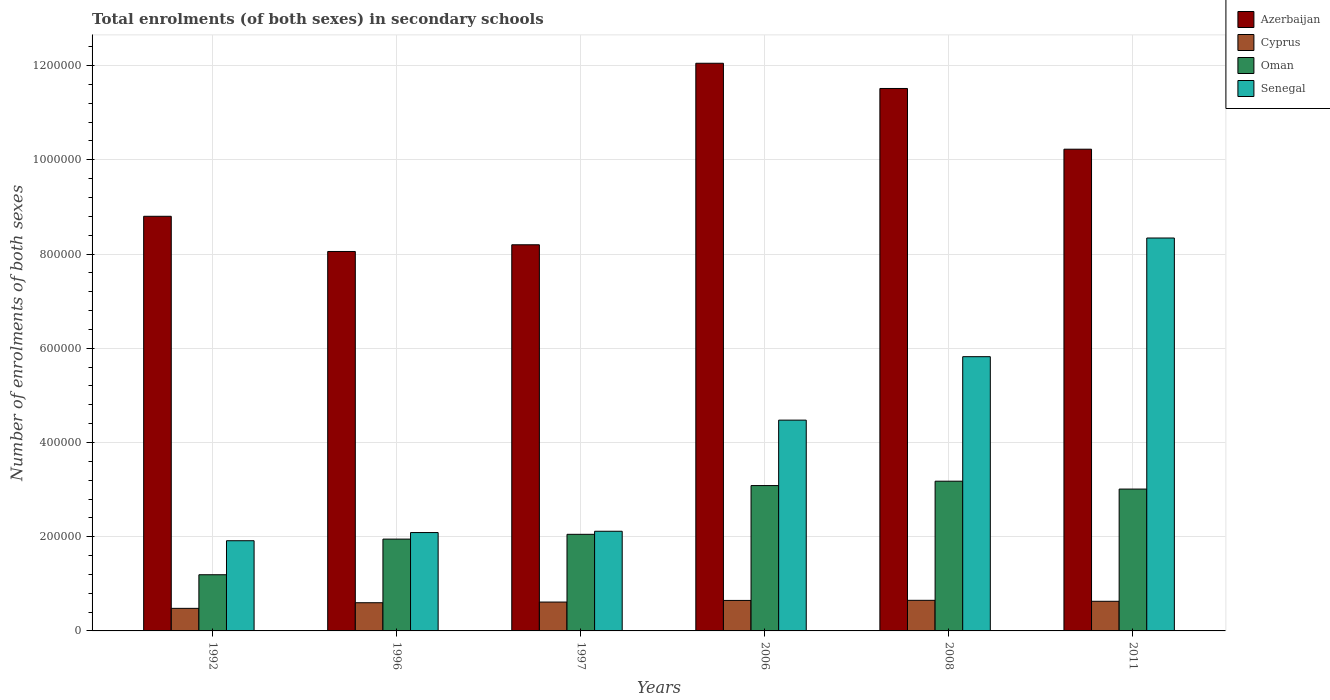How many different coloured bars are there?
Provide a short and direct response. 4. Are the number of bars per tick equal to the number of legend labels?
Your response must be concise. Yes. Are the number of bars on each tick of the X-axis equal?
Provide a succinct answer. Yes. What is the label of the 2nd group of bars from the left?
Keep it short and to the point. 1996. What is the number of enrolments in secondary schools in Oman in 1996?
Your answer should be very brief. 1.95e+05. Across all years, what is the maximum number of enrolments in secondary schools in Oman?
Offer a very short reply. 3.18e+05. Across all years, what is the minimum number of enrolments in secondary schools in Senegal?
Offer a terse response. 1.91e+05. In which year was the number of enrolments in secondary schools in Cyprus maximum?
Provide a short and direct response. 2008. In which year was the number of enrolments in secondary schools in Oman minimum?
Your answer should be compact. 1992. What is the total number of enrolments in secondary schools in Azerbaijan in the graph?
Your answer should be very brief. 5.88e+06. What is the difference between the number of enrolments in secondary schools in Azerbaijan in 2006 and that in 2011?
Provide a succinct answer. 1.82e+05. What is the difference between the number of enrolments in secondary schools in Cyprus in 1997 and the number of enrolments in secondary schools in Senegal in 1996?
Ensure brevity in your answer.  -1.48e+05. What is the average number of enrolments in secondary schools in Oman per year?
Provide a short and direct response. 2.41e+05. In the year 1992, what is the difference between the number of enrolments in secondary schools in Azerbaijan and number of enrolments in secondary schools in Oman?
Ensure brevity in your answer.  7.61e+05. In how many years, is the number of enrolments in secondary schools in Oman greater than 720000?
Offer a very short reply. 0. What is the ratio of the number of enrolments in secondary schools in Azerbaijan in 2008 to that in 2011?
Your response must be concise. 1.13. What is the difference between the highest and the second highest number of enrolments in secondary schools in Azerbaijan?
Provide a succinct answer. 5.35e+04. What is the difference between the highest and the lowest number of enrolments in secondary schools in Azerbaijan?
Ensure brevity in your answer.  4.00e+05. In how many years, is the number of enrolments in secondary schools in Senegal greater than the average number of enrolments in secondary schools in Senegal taken over all years?
Ensure brevity in your answer.  3. What does the 3rd bar from the left in 1996 represents?
Offer a terse response. Oman. What does the 3rd bar from the right in 2006 represents?
Your answer should be very brief. Cyprus. Is it the case that in every year, the sum of the number of enrolments in secondary schools in Azerbaijan and number of enrolments in secondary schools in Cyprus is greater than the number of enrolments in secondary schools in Oman?
Your answer should be compact. Yes. Are the values on the major ticks of Y-axis written in scientific E-notation?
Your response must be concise. No. Does the graph contain grids?
Your answer should be compact. Yes. Where does the legend appear in the graph?
Keep it short and to the point. Top right. How are the legend labels stacked?
Give a very brief answer. Vertical. What is the title of the graph?
Keep it short and to the point. Total enrolments (of both sexes) in secondary schools. What is the label or title of the X-axis?
Your answer should be very brief. Years. What is the label or title of the Y-axis?
Make the answer very short. Number of enrolments of both sexes. What is the Number of enrolments of both sexes of Azerbaijan in 1992?
Keep it short and to the point. 8.80e+05. What is the Number of enrolments of both sexes in Cyprus in 1992?
Provide a succinct answer. 4.79e+04. What is the Number of enrolments of both sexes in Oman in 1992?
Make the answer very short. 1.19e+05. What is the Number of enrolments of both sexes of Senegal in 1992?
Keep it short and to the point. 1.91e+05. What is the Number of enrolments of both sexes of Azerbaijan in 1996?
Make the answer very short. 8.05e+05. What is the Number of enrolments of both sexes of Cyprus in 1996?
Your response must be concise. 5.98e+04. What is the Number of enrolments of both sexes of Oman in 1996?
Provide a short and direct response. 1.95e+05. What is the Number of enrolments of both sexes in Senegal in 1996?
Keep it short and to the point. 2.09e+05. What is the Number of enrolments of both sexes in Azerbaijan in 1997?
Your answer should be compact. 8.20e+05. What is the Number of enrolments of both sexes in Cyprus in 1997?
Make the answer very short. 6.13e+04. What is the Number of enrolments of both sexes in Oman in 1997?
Give a very brief answer. 2.05e+05. What is the Number of enrolments of both sexes of Senegal in 1997?
Your answer should be compact. 2.12e+05. What is the Number of enrolments of both sexes in Azerbaijan in 2006?
Keep it short and to the point. 1.20e+06. What is the Number of enrolments of both sexes of Cyprus in 2006?
Keep it short and to the point. 6.47e+04. What is the Number of enrolments of both sexes of Oman in 2006?
Offer a very short reply. 3.09e+05. What is the Number of enrolments of both sexes of Senegal in 2006?
Provide a short and direct response. 4.47e+05. What is the Number of enrolments of both sexes of Azerbaijan in 2008?
Offer a very short reply. 1.15e+06. What is the Number of enrolments of both sexes of Cyprus in 2008?
Offer a very short reply. 6.50e+04. What is the Number of enrolments of both sexes of Oman in 2008?
Give a very brief answer. 3.18e+05. What is the Number of enrolments of both sexes of Senegal in 2008?
Your response must be concise. 5.82e+05. What is the Number of enrolments of both sexes of Azerbaijan in 2011?
Provide a succinct answer. 1.02e+06. What is the Number of enrolments of both sexes in Cyprus in 2011?
Your answer should be very brief. 6.29e+04. What is the Number of enrolments of both sexes in Oman in 2011?
Your answer should be very brief. 3.01e+05. What is the Number of enrolments of both sexes in Senegal in 2011?
Keep it short and to the point. 8.34e+05. Across all years, what is the maximum Number of enrolments of both sexes of Azerbaijan?
Provide a succinct answer. 1.20e+06. Across all years, what is the maximum Number of enrolments of both sexes of Cyprus?
Keep it short and to the point. 6.50e+04. Across all years, what is the maximum Number of enrolments of both sexes in Oman?
Provide a short and direct response. 3.18e+05. Across all years, what is the maximum Number of enrolments of both sexes in Senegal?
Your response must be concise. 8.34e+05. Across all years, what is the minimum Number of enrolments of both sexes in Azerbaijan?
Keep it short and to the point. 8.05e+05. Across all years, what is the minimum Number of enrolments of both sexes of Cyprus?
Provide a succinct answer. 4.79e+04. Across all years, what is the minimum Number of enrolments of both sexes in Oman?
Keep it short and to the point. 1.19e+05. Across all years, what is the minimum Number of enrolments of both sexes in Senegal?
Give a very brief answer. 1.91e+05. What is the total Number of enrolments of both sexes in Azerbaijan in the graph?
Your answer should be compact. 5.88e+06. What is the total Number of enrolments of both sexes of Cyprus in the graph?
Ensure brevity in your answer.  3.62e+05. What is the total Number of enrolments of both sexes of Oman in the graph?
Your response must be concise. 1.45e+06. What is the total Number of enrolments of both sexes in Senegal in the graph?
Offer a terse response. 2.48e+06. What is the difference between the Number of enrolments of both sexes in Azerbaijan in 1992 and that in 1996?
Offer a terse response. 7.47e+04. What is the difference between the Number of enrolments of both sexes in Cyprus in 1992 and that in 1996?
Keep it short and to the point. -1.19e+04. What is the difference between the Number of enrolments of both sexes of Oman in 1992 and that in 1996?
Give a very brief answer. -7.57e+04. What is the difference between the Number of enrolments of both sexes of Senegal in 1992 and that in 1996?
Give a very brief answer. -1.74e+04. What is the difference between the Number of enrolments of both sexes in Azerbaijan in 1992 and that in 1997?
Your response must be concise. 6.05e+04. What is the difference between the Number of enrolments of both sexes of Cyprus in 1992 and that in 1997?
Make the answer very short. -1.34e+04. What is the difference between the Number of enrolments of both sexes of Oman in 1992 and that in 1997?
Offer a very short reply. -8.58e+04. What is the difference between the Number of enrolments of both sexes of Senegal in 1992 and that in 1997?
Your answer should be very brief. -2.01e+04. What is the difference between the Number of enrolments of both sexes of Azerbaijan in 1992 and that in 2006?
Offer a terse response. -3.25e+05. What is the difference between the Number of enrolments of both sexes of Cyprus in 1992 and that in 2006?
Ensure brevity in your answer.  -1.68e+04. What is the difference between the Number of enrolments of both sexes in Oman in 1992 and that in 2006?
Keep it short and to the point. -1.89e+05. What is the difference between the Number of enrolments of both sexes in Senegal in 1992 and that in 2006?
Your response must be concise. -2.56e+05. What is the difference between the Number of enrolments of both sexes in Azerbaijan in 1992 and that in 2008?
Offer a terse response. -2.71e+05. What is the difference between the Number of enrolments of both sexes in Cyprus in 1992 and that in 2008?
Your answer should be compact. -1.71e+04. What is the difference between the Number of enrolments of both sexes in Oman in 1992 and that in 2008?
Provide a short and direct response. -1.99e+05. What is the difference between the Number of enrolments of both sexes of Senegal in 1992 and that in 2008?
Offer a very short reply. -3.91e+05. What is the difference between the Number of enrolments of both sexes in Azerbaijan in 1992 and that in 2011?
Give a very brief answer. -1.42e+05. What is the difference between the Number of enrolments of both sexes of Cyprus in 1992 and that in 2011?
Your answer should be compact. -1.50e+04. What is the difference between the Number of enrolments of both sexes of Oman in 1992 and that in 2011?
Keep it short and to the point. -1.82e+05. What is the difference between the Number of enrolments of both sexes in Senegal in 1992 and that in 2011?
Provide a short and direct response. -6.43e+05. What is the difference between the Number of enrolments of both sexes of Azerbaijan in 1996 and that in 1997?
Provide a short and direct response. -1.42e+04. What is the difference between the Number of enrolments of both sexes in Cyprus in 1996 and that in 1997?
Provide a short and direct response. -1421. What is the difference between the Number of enrolments of both sexes of Oman in 1996 and that in 1997?
Ensure brevity in your answer.  -1.01e+04. What is the difference between the Number of enrolments of both sexes of Senegal in 1996 and that in 1997?
Ensure brevity in your answer.  -2772. What is the difference between the Number of enrolments of both sexes of Azerbaijan in 1996 and that in 2006?
Give a very brief answer. -4.00e+05. What is the difference between the Number of enrolments of both sexes in Cyprus in 1996 and that in 2006?
Provide a short and direct response. -4869. What is the difference between the Number of enrolments of both sexes of Oman in 1996 and that in 2006?
Make the answer very short. -1.14e+05. What is the difference between the Number of enrolments of both sexes in Senegal in 1996 and that in 2006?
Keep it short and to the point. -2.39e+05. What is the difference between the Number of enrolments of both sexes of Azerbaijan in 1996 and that in 2008?
Offer a terse response. -3.46e+05. What is the difference between the Number of enrolments of both sexes in Cyprus in 1996 and that in 2008?
Your answer should be very brief. -5121. What is the difference between the Number of enrolments of both sexes of Oman in 1996 and that in 2008?
Give a very brief answer. -1.23e+05. What is the difference between the Number of enrolments of both sexes of Senegal in 1996 and that in 2008?
Make the answer very short. -3.73e+05. What is the difference between the Number of enrolments of both sexes in Azerbaijan in 1996 and that in 2011?
Your answer should be compact. -2.17e+05. What is the difference between the Number of enrolments of both sexes in Cyprus in 1996 and that in 2011?
Offer a terse response. -3049. What is the difference between the Number of enrolments of both sexes of Oman in 1996 and that in 2011?
Offer a terse response. -1.06e+05. What is the difference between the Number of enrolments of both sexes in Senegal in 1996 and that in 2011?
Offer a very short reply. -6.25e+05. What is the difference between the Number of enrolments of both sexes in Azerbaijan in 1997 and that in 2006?
Provide a short and direct response. -3.85e+05. What is the difference between the Number of enrolments of both sexes in Cyprus in 1997 and that in 2006?
Offer a very short reply. -3448. What is the difference between the Number of enrolments of both sexes in Oman in 1997 and that in 2006?
Your response must be concise. -1.03e+05. What is the difference between the Number of enrolments of both sexes of Senegal in 1997 and that in 2006?
Offer a very short reply. -2.36e+05. What is the difference between the Number of enrolments of both sexes of Azerbaijan in 1997 and that in 2008?
Offer a terse response. -3.32e+05. What is the difference between the Number of enrolments of both sexes of Cyprus in 1997 and that in 2008?
Ensure brevity in your answer.  -3700. What is the difference between the Number of enrolments of both sexes of Oman in 1997 and that in 2008?
Offer a very short reply. -1.13e+05. What is the difference between the Number of enrolments of both sexes of Senegal in 1997 and that in 2008?
Offer a terse response. -3.71e+05. What is the difference between the Number of enrolments of both sexes of Azerbaijan in 1997 and that in 2011?
Keep it short and to the point. -2.03e+05. What is the difference between the Number of enrolments of both sexes in Cyprus in 1997 and that in 2011?
Provide a succinct answer. -1628. What is the difference between the Number of enrolments of both sexes in Oman in 1997 and that in 2011?
Offer a terse response. -9.60e+04. What is the difference between the Number of enrolments of both sexes of Senegal in 1997 and that in 2011?
Make the answer very short. -6.22e+05. What is the difference between the Number of enrolments of both sexes in Azerbaijan in 2006 and that in 2008?
Ensure brevity in your answer.  5.35e+04. What is the difference between the Number of enrolments of both sexes in Cyprus in 2006 and that in 2008?
Keep it short and to the point. -252. What is the difference between the Number of enrolments of both sexes in Oman in 2006 and that in 2008?
Your answer should be compact. -9308. What is the difference between the Number of enrolments of both sexes of Senegal in 2006 and that in 2008?
Provide a succinct answer. -1.35e+05. What is the difference between the Number of enrolments of both sexes in Azerbaijan in 2006 and that in 2011?
Ensure brevity in your answer.  1.82e+05. What is the difference between the Number of enrolments of both sexes of Cyprus in 2006 and that in 2011?
Make the answer very short. 1820. What is the difference between the Number of enrolments of both sexes in Oman in 2006 and that in 2011?
Provide a short and direct response. 7435. What is the difference between the Number of enrolments of both sexes of Senegal in 2006 and that in 2011?
Ensure brevity in your answer.  -3.87e+05. What is the difference between the Number of enrolments of both sexes of Azerbaijan in 2008 and that in 2011?
Your answer should be very brief. 1.29e+05. What is the difference between the Number of enrolments of both sexes of Cyprus in 2008 and that in 2011?
Offer a terse response. 2072. What is the difference between the Number of enrolments of both sexes of Oman in 2008 and that in 2011?
Offer a terse response. 1.67e+04. What is the difference between the Number of enrolments of both sexes in Senegal in 2008 and that in 2011?
Keep it short and to the point. -2.52e+05. What is the difference between the Number of enrolments of both sexes in Azerbaijan in 1992 and the Number of enrolments of both sexes in Cyprus in 1996?
Ensure brevity in your answer.  8.20e+05. What is the difference between the Number of enrolments of both sexes of Azerbaijan in 1992 and the Number of enrolments of both sexes of Oman in 1996?
Your answer should be compact. 6.85e+05. What is the difference between the Number of enrolments of both sexes of Azerbaijan in 1992 and the Number of enrolments of both sexes of Senegal in 1996?
Ensure brevity in your answer.  6.71e+05. What is the difference between the Number of enrolments of both sexes in Cyprus in 1992 and the Number of enrolments of both sexes in Oman in 1996?
Provide a short and direct response. -1.47e+05. What is the difference between the Number of enrolments of both sexes in Cyprus in 1992 and the Number of enrolments of both sexes in Senegal in 1996?
Provide a short and direct response. -1.61e+05. What is the difference between the Number of enrolments of both sexes in Oman in 1992 and the Number of enrolments of both sexes in Senegal in 1996?
Provide a short and direct response. -8.95e+04. What is the difference between the Number of enrolments of both sexes of Azerbaijan in 1992 and the Number of enrolments of both sexes of Cyprus in 1997?
Make the answer very short. 8.19e+05. What is the difference between the Number of enrolments of both sexes of Azerbaijan in 1992 and the Number of enrolments of both sexes of Oman in 1997?
Your answer should be compact. 6.75e+05. What is the difference between the Number of enrolments of both sexes in Azerbaijan in 1992 and the Number of enrolments of both sexes in Senegal in 1997?
Offer a terse response. 6.69e+05. What is the difference between the Number of enrolments of both sexes of Cyprus in 1992 and the Number of enrolments of both sexes of Oman in 1997?
Your response must be concise. -1.57e+05. What is the difference between the Number of enrolments of both sexes in Cyprus in 1992 and the Number of enrolments of both sexes in Senegal in 1997?
Keep it short and to the point. -1.64e+05. What is the difference between the Number of enrolments of both sexes in Oman in 1992 and the Number of enrolments of both sexes in Senegal in 1997?
Your answer should be compact. -9.23e+04. What is the difference between the Number of enrolments of both sexes in Azerbaijan in 1992 and the Number of enrolments of both sexes in Cyprus in 2006?
Make the answer very short. 8.15e+05. What is the difference between the Number of enrolments of both sexes of Azerbaijan in 1992 and the Number of enrolments of both sexes of Oman in 2006?
Your response must be concise. 5.72e+05. What is the difference between the Number of enrolments of both sexes in Azerbaijan in 1992 and the Number of enrolments of both sexes in Senegal in 2006?
Give a very brief answer. 4.33e+05. What is the difference between the Number of enrolments of both sexes in Cyprus in 1992 and the Number of enrolments of both sexes in Oman in 2006?
Offer a terse response. -2.61e+05. What is the difference between the Number of enrolments of both sexes of Cyprus in 1992 and the Number of enrolments of both sexes of Senegal in 2006?
Your response must be concise. -4.00e+05. What is the difference between the Number of enrolments of both sexes in Oman in 1992 and the Number of enrolments of both sexes in Senegal in 2006?
Your answer should be very brief. -3.28e+05. What is the difference between the Number of enrolments of both sexes in Azerbaijan in 1992 and the Number of enrolments of both sexes in Cyprus in 2008?
Offer a terse response. 8.15e+05. What is the difference between the Number of enrolments of both sexes of Azerbaijan in 1992 and the Number of enrolments of both sexes of Oman in 2008?
Provide a short and direct response. 5.62e+05. What is the difference between the Number of enrolments of both sexes in Azerbaijan in 1992 and the Number of enrolments of both sexes in Senegal in 2008?
Ensure brevity in your answer.  2.98e+05. What is the difference between the Number of enrolments of both sexes in Cyprus in 1992 and the Number of enrolments of both sexes in Oman in 2008?
Ensure brevity in your answer.  -2.70e+05. What is the difference between the Number of enrolments of both sexes in Cyprus in 1992 and the Number of enrolments of both sexes in Senegal in 2008?
Give a very brief answer. -5.34e+05. What is the difference between the Number of enrolments of both sexes of Oman in 1992 and the Number of enrolments of both sexes of Senegal in 2008?
Provide a succinct answer. -4.63e+05. What is the difference between the Number of enrolments of both sexes in Azerbaijan in 1992 and the Number of enrolments of both sexes in Cyprus in 2011?
Provide a short and direct response. 8.17e+05. What is the difference between the Number of enrolments of both sexes of Azerbaijan in 1992 and the Number of enrolments of both sexes of Oman in 2011?
Keep it short and to the point. 5.79e+05. What is the difference between the Number of enrolments of both sexes of Azerbaijan in 1992 and the Number of enrolments of both sexes of Senegal in 2011?
Provide a short and direct response. 4.61e+04. What is the difference between the Number of enrolments of both sexes in Cyprus in 1992 and the Number of enrolments of both sexes in Oman in 2011?
Your answer should be very brief. -2.53e+05. What is the difference between the Number of enrolments of both sexes of Cyprus in 1992 and the Number of enrolments of both sexes of Senegal in 2011?
Ensure brevity in your answer.  -7.86e+05. What is the difference between the Number of enrolments of both sexes of Oman in 1992 and the Number of enrolments of both sexes of Senegal in 2011?
Give a very brief answer. -7.15e+05. What is the difference between the Number of enrolments of both sexes in Azerbaijan in 1996 and the Number of enrolments of both sexes in Cyprus in 1997?
Your response must be concise. 7.44e+05. What is the difference between the Number of enrolments of both sexes in Azerbaijan in 1996 and the Number of enrolments of both sexes in Oman in 1997?
Give a very brief answer. 6.00e+05. What is the difference between the Number of enrolments of both sexes in Azerbaijan in 1996 and the Number of enrolments of both sexes in Senegal in 1997?
Offer a very short reply. 5.94e+05. What is the difference between the Number of enrolments of both sexes in Cyprus in 1996 and the Number of enrolments of both sexes in Oman in 1997?
Ensure brevity in your answer.  -1.45e+05. What is the difference between the Number of enrolments of both sexes in Cyprus in 1996 and the Number of enrolments of both sexes in Senegal in 1997?
Your response must be concise. -1.52e+05. What is the difference between the Number of enrolments of both sexes in Oman in 1996 and the Number of enrolments of both sexes in Senegal in 1997?
Offer a terse response. -1.67e+04. What is the difference between the Number of enrolments of both sexes in Azerbaijan in 1996 and the Number of enrolments of both sexes in Cyprus in 2006?
Give a very brief answer. 7.41e+05. What is the difference between the Number of enrolments of both sexes in Azerbaijan in 1996 and the Number of enrolments of both sexes in Oman in 2006?
Ensure brevity in your answer.  4.97e+05. What is the difference between the Number of enrolments of both sexes in Azerbaijan in 1996 and the Number of enrolments of both sexes in Senegal in 2006?
Your response must be concise. 3.58e+05. What is the difference between the Number of enrolments of both sexes in Cyprus in 1996 and the Number of enrolments of both sexes in Oman in 2006?
Offer a terse response. -2.49e+05. What is the difference between the Number of enrolments of both sexes in Cyprus in 1996 and the Number of enrolments of both sexes in Senegal in 2006?
Give a very brief answer. -3.88e+05. What is the difference between the Number of enrolments of both sexes in Oman in 1996 and the Number of enrolments of both sexes in Senegal in 2006?
Offer a very short reply. -2.53e+05. What is the difference between the Number of enrolments of both sexes of Azerbaijan in 1996 and the Number of enrolments of both sexes of Cyprus in 2008?
Keep it short and to the point. 7.40e+05. What is the difference between the Number of enrolments of both sexes in Azerbaijan in 1996 and the Number of enrolments of both sexes in Oman in 2008?
Keep it short and to the point. 4.88e+05. What is the difference between the Number of enrolments of both sexes of Azerbaijan in 1996 and the Number of enrolments of both sexes of Senegal in 2008?
Your answer should be very brief. 2.23e+05. What is the difference between the Number of enrolments of both sexes in Cyprus in 1996 and the Number of enrolments of both sexes in Oman in 2008?
Your answer should be compact. -2.58e+05. What is the difference between the Number of enrolments of both sexes of Cyprus in 1996 and the Number of enrolments of both sexes of Senegal in 2008?
Your response must be concise. -5.22e+05. What is the difference between the Number of enrolments of both sexes of Oman in 1996 and the Number of enrolments of both sexes of Senegal in 2008?
Keep it short and to the point. -3.87e+05. What is the difference between the Number of enrolments of both sexes of Azerbaijan in 1996 and the Number of enrolments of both sexes of Cyprus in 2011?
Give a very brief answer. 7.42e+05. What is the difference between the Number of enrolments of both sexes in Azerbaijan in 1996 and the Number of enrolments of both sexes in Oman in 2011?
Offer a very short reply. 5.04e+05. What is the difference between the Number of enrolments of both sexes of Azerbaijan in 1996 and the Number of enrolments of both sexes of Senegal in 2011?
Provide a short and direct response. -2.86e+04. What is the difference between the Number of enrolments of both sexes in Cyprus in 1996 and the Number of enrolments of both sexes in Oman in 2011?
Provide a short and direct response. -2.41e+05. What is the difference between the Number of enrolments of both sexes of Cyprus in 1996 and the Number of enrolments of both sexes of Senegal in 2011?
Provide a short and direct response. -7.74e+05. What is the difference between the Number of enrolments of both sexes of Oman in 1996 and the Number of enrolments of both sexes of Senegal in 2011?
Provide a short and direct response. -6.39e+05. What is the difference between the Number of enrolments of both sexes in Azerbaijan in 1997 and the Number of enrolments of both sexes in Cyprus in 2006?
Offer a very short reply. 7.55e+05. What is the difference between the Number of enrolments of both sexes of Azerbaijan in 1997 and the Number of enrolments of both sexes of Oman in 2006?
Give a very brief answer. 5.11e+05. What is the difference between the Number of enrolments of both sexes of Azerbaijan in 1997 and the Number of enrolments of both sexes of Senegal in 2006?
Make the answer very short. 3.72e+05. What is the difference between the Number of enrolments of both sexes of Cyprus in 1997 and the Number of enrolments of both sexes of Oman in 2006?
Give a very brief answer. -2.47e+05. What is the difference between the Number of enrolments of both sexes of Cyprus in 1997 and the Number of enrolments of both sexes of Senegal in 2006?
Offer a very short reply. -3.86e+05. What is the difference between the Number of enrolments of both sexes in Oman in 1997 and the Number of enrolments of both sexes in Senegal in 2006?
Give a very brief answer. -2.42e+05. What is the difference between the Number of enrolments of both sexes in Azerbaijan in 1997 and the Number of enrolments of both sexes in Cyprus in 2008?
Give a very brief answer. 7.55e+05. What is the difference between the Number of enrolments of both sexes of Azerbaijan in 1997 and the Number of enrolments of both sexes of Oman in 2008?
Offer a very short reply. 5.02e+05. What is the difference between the Number of enrolments of both sexes in Azerbaijan in 1997 and the Number of enrolments of both sexes in Senegal in 2008?
Provide a succinct answer. 2.38e+05. What is the difference between the Number of enrolments of both sexes in Cyprus in 1997 and the Number of enrolments of both sexes in Oman in 2008?
Your answer should be compact. -2.57e+05. What is the difference between the Number of enrolments of both sexes of Cyprus in 1997 and the Number of enrolments of both sexes of Senegal in 2008?
Ensure brevity in your answer.  -5.21e+05. What is the difference between the Number of enrolments of both sexes in Oman in 1997 and the Number of enrolments of both sexes in Senegal in 2008?
Offer a very short reply. -3.77e+05. What is the difference between the Number of enrolments of both sexes of Azerbaijan in 1997 and the Number of enrolments of both sexes of Cyprus in 2011?
Ensure brevity in your answer.  7.57e+05. What is the difference between the Number of enrolments of both sexes of Azerbaijan in 1997 and the Number of enrolments of both sexes of Oman in 2011?
Offer a very short reply. 5.19e+05. What is the difference between the Number of enrolments of both sexes in Azerbaijan in 1997 and the Number of enrolments of both sexes in Senegal in 2011?
Offer a terse response. -1.43e+04. What is the difference between the Number of enrolments of both sexes of Cyprus in 1997 and the Number of enrolments of both sexes of Oman in 2011?
Provide a succinct answer. -2.40e+05. What is the difference between the Number of enrolments of both sexes in Cyprus in 1997 and the Number of enrolments of both sexes in Senegal in 2011?
Offer a terse response. -7.73e+05. What is the difference between the Number of enrolments of both sexes in Oman in 1997 and the Number of enrolments of both sexes in Senegal in 2011?
Offer a terse response. -6.29e+05. What is the difference between the Number of enrolments of both sexes in Azerbaijan in 2006 and the Number of enrolments of both sexes in Cyprus in 2008?
Provide a succinct answer. 1.14e+06. What is the difference between the Number of enrolments of both sexes in Azerbaijan in 2006 and the Number of enrolments of both sexes in Oman in 2008?
Make the answer very short. 8.87e+05. What is the difference between the Number of enrolments of both sexes of Azerbaijan in 2006 and the Number of enrolments of both sexes of Senegal in 2008?
Provide a succinct answer. 6.23e+05. What is the difference between the Number of enrolments of both sexes of Cyprus in 2006 and the Number of enrolments of both sexes of Oman in 2008?
Your answer should be very brief. -2.53e+05. What is the difference between the Number of enrolments of both sexes in Cyprus in 2006 and the Number of enrolments of both sexes in Senegal in 2008?
Your answer should be very brief. -5.17e+05. What is the difference between the Number of enrolments of both sexes of Oman in 2006 and the Number of enrolments of both sexes of Senegal in 2008?
Give a very brief answer. -2.74e+05. What is the difference between the Number of enrolments of both sexes of Azerbaijan in 2006 and the Number of enrolments of both sexes of Cyprus in 2011?
Offer a very short reply. 1.14e+06. What is the difference between the Number of enrolments of both sexes in Azerbaijan in 2006 and the Number of enrolments of both sexes in Oman in 2011?
Provide a short and direct response. 9.04e+05. What is the difference between the Number of enrolments of both sexes of Azerbaijan in 2006 and the Number of enrolments of both sexes of Senegal in 2011?
Offer a very short reply. 3.71e+05. What is the difference between the Number of enrolments of both sexes in Cyprus in 2006 and the Number of enrolments of both sexes in Oman in 2011?
Provide a short and direct response. -2.36e+05. What is the difference between the Number of enrolments of both sexes of Cyprus in 2006 and the Number of enrolments of both sexes of Senegal in 2011?
Make the answer very short. -7.69e+05. What is the difference between the Number of enrolments of both sexes in Oman in 2006 and the Number of enrolments of both sexes in Senegal in 2011?
Your answer should be very brief. -5.25e+05. What is the difference between the Number of enrolments of both sexes in Azerbaijan in 2008 and the Number of enrolments of both sexes in Cyprus in 2011?
Make the answer very short. 1.09e+06. What is the difference between the Number of enrolments of both sexes in Azerbaijan in 2008 and the Number of enrolments of both sexes in Oman in 2011?
Provide a succinct answer. 8.50e+05. What is the difference between the Number of enrolments of both sexes of Azerbaijan in 2008 and the Number of enrolments of both sexes of Senegal in 2011?
Ensure brevity in your answer.  3.17e+05. What is the difference between the Number of enrolments of both sexes in Cyprus in 2008 and the Number of enrolments of both sexes in Oman in 2011?
Ensure brevity in your answer.  -2.36e+05. What is the difference between the Number of enrolments of both sexes of Cyprus in 2008 and the Number of enrolments of both sexes of Senegal in 2011?
Give a very brief answer. -7.69e+05. What is the difference between the Number of enrolments of both sexes of Oman in 2008 and the Number of enrolments of both sexes of Senegal in 2011?
Your answer should be very brief. -5.16e+05. What is the average Number of enrolments of both sexes in Azerbaijan per year?
Offer a terse response. 9.81e+05. What is the average Number of enrolments of both sexes of Cyprus per year?
Your answer should be compact. 6.03e+04. What is the average Number of enrolments of both sexes of Oman per year?
Offer a terse response. 2.41e+05. What is the average Number of enrolments of both sexes of Senegal per year?
Ensure brevity in your answer.  4.13e+05. In the year 1992, what is the difference between the Number of enrolments of both sexes in Azerbaijan and Number of enrolments of both sexes in Cyprus?
Your answer should be compact. 8.32e+05. In the year 1992, what is the difference between the Number of enrolments of both sexes of Azerbaijan and Number of enrolments of both sexes of Oman?
Give a very brief answer. 7.61e+05. In the year 1992, what is the difference between the Number of enrolments of both sexes of Azerbaijan and Number of enrolments of both sexes of Senegal?
Provide a short and direct response. 6.89e+05. In the year 1992, what is the difference between the Number of enrolments of both sexes in Cyprus and Number of enrolments of both sexes in Oman?
Your answer should be compact. -7.13e+04. In the year 1992, what is the difference between the Number of enrolments of both sexes of Cyprus and Number of enrolments of both sexes of Senegal?
Keep it short and to the point. -1.44e+05. In the year 1992, what is the difference between the Number of enrolments of both sexes in Oman and Number of enrolments of both sexes in Senegal?
Ensure brevity in your answer.  -7.22e+04. In the year 1996, what is the difference between the Number of enrolments of both sexes of Azerbaijan and Number of enrolments of both sexes of Cyprus?
Ensure brevity in your answer.  7.46e+05. In the year 1996, what is the difference between the Number of enrolments of both sexes of Azerbaijan and Number of enrolments of both sexes of Oman?
Your response must be concise. 6.10e+05. In the year 1996, what is the difference between the Number of enrolments of both sexes in Azerbaijan and Number of enrolments of both sexes in Senegal?
Provide a short and direct response. 5.97e+05. In the year 1996, what is the difference between the Number of enrolments of both sexes in Cyprus and Number of enrolments of both sexes in Oman?
Your answer should be compact. -1.35e+05. In the year 1996, what is the difference between the Number of enrolments of both sexes of Cyprus and Number of enrolments of both sexes of Senegal?
Make the answer very short. -1.49e+05. In the year 1996, what is the difference between the Number of enrolments of both sexes in Oman and Number of enrolments of both sexes in Senegal?
Make the answer very short. -1.39e+04. In the year 1997, what is the difference between the Number of enrolments of both sexes in Azerbaijan and Number of enrolments of both sexes in Cyprus?
Give a very brief answer. 7.58e+05. In the year 1997, what is the difference between the Number of enrolments of both sexes in Azerbaijan and Number of enrolments of both sexes in Oman?
Make the answer very short. 6.15e+05. In the year 1997, what is the difference between the Number of enrolments of both sexes in Azerbaijan and Number of enrolments of both sexes in Senegal?
Offer a terse response. 6.08e+05. In the year 1997, what is the difference between the Number of enrolments of both sexes of Cyprus and Number of enrolments of both sexes of Oman?
Your answer should be very brief. -1.44e+05. In the year 1997, what is the difference between the Number of enrolments of both sexes in Cyprus and Number of enrolments of both sexes in Senegal?
Keep it short and to the point. -1.50e+05. In the year 1997, what is the difference between the Number of enrolments of both sexes in Oman and Number of enrolments of both sexes in Senegal?
Give a very brief answer. -6512. In the year 2006, what is the difference between the Number of enrolments of both sexes in Azerbaijan and Number of enrolments of both sexes in Cyprus?
Provide a short and direct response. 1.14e+06. In the year 2006, what is the difference between the Number of enrolments of both sexes of Azerbaijan and Number of enrolments of both sexes of Oman?
Your answer should be very brief. 8.96e+05. In the year 2006, what is the difference between the Number of enrolments of both sexes of Azerbaijan and Number of enrolments of both sexes of Senegal?
Provide a short and direct response. 7.57e+05. In the year 2006, what is the difference between the Number of enrolments of both sexes in Cyprus and Number of enrolments of both sexes in Oman?
Your response must be concise. -2.44e+05. In the year 2006, what is the difference between the Number of enrolments of both sexes in Cyprus and Number of enrolments of both sexes in Senegal?
Offer a very short reply. -3.83e+05. In the year 2006, what is the difference between the Number of enrolments of both sexes in Oman and Number of enrolments of both sexes in Senegal?
Your answer should be compact. -1.39e+05. In the year 2008, what is the difference between the Number of enrolments of both sexes of Azerbaijan and Number of enrolments of both sexes of Cyprus?
Give a very brief answer. 1.09e+06. In the year 2008, what is the difference between the Number of enrolments of both sexes in Azerbaijan and Number of enrolments of both sexes in Oman?
Keep it short and to the point. 8.34e+05. In the year 2008, what is the difference between the Number of enrolments of both sexes of Azerbaijan and Number of enrolments of both sexes of Senegal?
Offer a terse response. 5.69e+05. In the year 2008, what is the difference between the Number of enrolments of both sexes of Cyprus and Number of enrolments of both sexes of Oman?
Offer a terse response. -2.53e+05. In the year 2008, what is the difference between the Number of enrolments of both sexes in Cyprus and Number of enrolments of both sexes in Senegal?
Give a very brief answer. -5.17e+05. In the year 2008, what is the difference between the Number of enrolments of both sexes of Oman and Number of enrolments of both sexes of Senegal?
Keep it short and to the point. -2.64e+05. In the year 2011, what is the difference between the Number of enrolments of both sexes of Azerbaijan and Number of enrolments of both sexes of Cyprus?
Your answer should be compact. 9.60e+05. In the year 2011, what is the difference between the Number of enrolments of both sexes in Azerbaijan and Number of enrolments of both sexes in Oman?
Provide a short and direct response. 7.21e+05. In the year 2011, what is the difference between the Number of enrolments of both sexes in Azerbaijan and Number of enrolments of both sexes in Senegal?
Give a very brief answer. 1.89e+05. In the year 2011, what is the difference between the Number of enrolments of both sexes in Cyprus and Number of enrolments of both sexes in Oman?
Offer a very short reply. -2.38e+05. In the year 2011, what is the difference between the Number of enrolments of both sexes in Cyprus and Number of enrolments of both sexes in Senegal?
Provide a short and direct response. -7.71e+05. In the year 2011, what is the difference between the Number of enrolments of both sexes in Oman and Number of enrolments of both sexes in Senegal?
Your response must be concise. -5.33e+05. What is the ratio of the Number of enrolments of both sexes of Azerbaijan in 1992 to that in 1996?
Your response must be concise. 1.09. What is the ratio of the Number of enrolments of both sexes in Cyprus in 1992 to that in 1996?
Your response must be concise. 0.8. What is the ratio of the Number of enrolments of both sexes in Oman in 1992 to that in 1996?
Your answer should be compact. 0.61. What is the ratio of the Number of enrolments of both sexes of Senegal in 1992 to that in 1996?
Your response must be concise. 0.92. What is the ratio of the Number of enrolments of both sexes of Azerbaijan in 1992 to that in 1997?
Your answer should be compact. 1.07. What is the ratio of the Number of enrolments of both sexes of Cyprus in 1992 to that in 1997?
Offer a very short reply. 0.78. What is the ratio of the Number of enrolments of both sexes in Oman in 1992 to that in 1997?
Give a very brief answer. 0.58. What is the ratio of the Number of enrolments of both sexes of Senegal in 1992 to that in 1997?
Keep it short and to the point. 0.9. What is the ratio of the Number of enrolments of both sexes of Azerbaijan in 1992 to that in 2006?
Your answer should be compact. 0.73. What is the ratio of the Number of enrolments of both sexes of Cyprus in 1992 to that in 2006?
Provide a short and direct response. 0.74. What is the ratio of the Number of enrolments of both sexes of Oman in 1992 to that in 2006?
Give a very brief answer. 0.39. What is the ratio of the Number of enrolments of both sexes of Senegal in 1992 to that in 2006?
Your answer should be very brief. 0.43. What is the ratio of the Number of enrolments of both sexes in Azerbaijan in 1992 to that in 2008?
Offer a terse response. 0.76. What is the ratio of the Number of enrolments of both sexes of Cyprus in 1992 to that in 2008?
Provide a short and direct response. 0.74. What is the ratio of the Number of enrolments of both sexes of Oman in 1992 to that in 2008?
Offer a very short reply. 0.38. What is the ratio of the Number of enrolments of both sexes in Senegal in 1992 to that in 2008?
Your response must be concise. 0.33. What is the ratio of the Number of enrolments of both sexes in Azerbaijan in 1992 to that in 2011?
Your answer should be very brief. 0.86. What is the ratio of the Number of enrolments of both sexes in Cyprus in 1992 to that in 2011?
Offer a very short reply. 0.76. What is the ratio of the Number of enrolments of both sexes in Oman in 1992 to that in 2011?
Your answer should be very brief. 0.4. What is the ratio of the Number of enrolments of both sexes in Senegal in 1992 to that in 2011?
Provide a short and direct response. 0.23. What is the ratio of the Number of enrolments of both sexes in Azerbaijan in 1996 to that in 1997?
Give a very brief answer. 0.98. What is the ratio of the Number of enrolments of both sexes of Cyprus in 1996 to that in 1997?
Keep it short and to the point. 0.98. What is the ratio of the Number of enrolments of both sexes of Oman in 1996 to that in 1997?
Provide a short and direct response. 0.95. What is the ratio of the Number of enrolments of both sexes in Senegal in 1996 to that in 1997?
Your answer should be very brief. 0.99. What is the ratio of the Number of enrolments of both sexes in Azerbaijan in 1996 to that in 2006?
Give a very brief answer. 0.67. What is the ratio of the Number of enrolments of both sexes of Cyprus in 1996 to that in 2006?
Make the answer very short. 0.92. What is the ratio of the Number of enrolments of both sexes in Oman in 1996 to that in 2006?
Ensure brevity in your answer.  0.63. What is the ratio of the Number of enrolments of both sexes in Senegal in 1996 to that in 2006?
Make the answer very short. 0.47. What is the ratio of the Number of enrolments of both sexes of Azerbaijan in 1996 to that in 2008?
Ensure brevity in your answer.  0.7. What is the ratio of the Number of enrolments of both sexes of Cyprus in 1996 to that in 2008?
Give a very brief answer. 0.92. What is the ratio of the Number of enrolments of both sexes of Oman in 1996 to that in 2008?
Provide a short and direct response. 0.61. What is the ratio of the Number of enrolments of both sexes in Senegal in 1996 to that in 2008?
Give a very brief answer. 0.36. What is the ratio of the Number of enrolments of both sexes of Azerbaijan in 1996 to that in 2011?
Offer a terse response. 0.79. What is the ratio of the Number of enrolments of both sexes in Cyprus in 1996 to that in 2011?
Make the answer very short. 0.95. What is the ratio of the Number of enrolments of both sexes in Oman in 1996 to that in 2011?
Give a very brief answer. 0.65. What is the ratio of the Number of enrolments of both sexes of Senegal in 1996 to that in 2011?
Make the answer very short. 0.25. What is the ratio of the Number of enrolments of both sexes in Azerbaijan in 1997 to that in 2006?
Provide a succinct answer. 0.68. What is the ratio of the Number of enrolments of both sexes of Cyprus in 1997 to that in 2006?
Give a very brief answer. 0.95. What is the ratio of the Number of enrolments of both sexes in Oman in 1997 to that in 2006?
Ensure brevity in your answer.  0.66. What is the ratio of the Number of enrolments of both sexes in Senegal in 1997 to that in 2006?
Your answer should be compact. 0.47. What is the ratio of the Number of enrolments of both sexes of Azerbaijan in 1997 to that in 2008?
Your answer should be compact. 0.71. What is the ratio of the Number of enrolments of both sexes of Cyprus in 1997 to that in 2008?
Ensure brevity in your answer.  0.94. What is the ratio of the Number of enrolments of both sexes in Oman in 1997 to that in 2008?
Provide a succinct answer. 0.65. What is the ratio of the Number of enrolments of both sexes of Senegal in 1997 to that in 2008?
Ensure brevity in your answer.  0.36. What is the ratio of the Number of enrolments of both sexes of Azerbaijan in 1997 to that in 2011?
Provide a short and direct response. 0.8. What is the ratio of the Number of enrolments of both sexes of Cyprus in 1997 to that in 2011?
Provide a short and direct response. 0.97. What is the ratio of the Number of enrolments of both sexes in Oman in 1997 to that in 2011?
Your answer should be compact. 0.68. What is the ratio of the Number of enrolments of both sexes in Senegal in 1997 to that in 2011?
Offer a terse response. 0.25. What is the ratio of the Number of enrolments of both sexes in Azerbaijan in 2006 to that in 2008?
Make the answer very short. 1.05. What is the ratio of the Number of enrolments of both sexes in Oman in 2006 to that in 2008?
Your answer should be very brief. 0.97. What is the ratio of the Number of enrolments of both sexes of Senegal in 2006 to that in 2008?
Offer a very short reply. 0.77. What is the ratio of the Number of enrolments of both sexes of Azerbaijan in 2006 to that in 2011?
Offer a terse response. 1.18. What is the ratio of the Number of enrolments of both sexes of Cyprus in 2006 to that in 2011?
Make the answer very short. 1.03. What is the ratio of the Number of enrolments of both sexes in Oman in 2006 to that in 2011?
Keep it short and to the point. 1.02. What is the ratio of the Number of enrolments of both sexes of Senegal in 2006 to that in 2011?
Your answer should be compact. 0.54. What is the ratio of the Number of enrolments of both sexes in Azerbaijan in 2008 to that in 2011?
Provide a succinct answer. 1.13. What is the ratio of the Number of enrolments of both sexes in Cyprus in 2008 to that in 2011?
Your response must be concise. 1.03. What is the ratio of the Number of enrolments of both sexes of Oman in 2008 to that in 2011?
Your response must be concise. 1.06. What is the ratio of the Number of enrolments of both sexes in Senegal in 2008 to that in 2011?
Keep it short and to the point. 0.7. What is the difference between the highest and the second highest Number of enrolments of both sexes of Azerbaijan?
Ensure brevity in your answer.  5.35e+04. What is the difference between the highest and the second highest Number of enrolments of both sexes of Cyprus?
Offer a terse response. 252. What is the difference between the highest and the second highest Number of enrolments of both sexes in Oman?
Provide a short and direct response. 9308. What is the difference between the highest and the second highest Number of enrolments of both sexes of Senegal?
Offer a terse response. 2.52e+05. What is the difference between the highest and the lowest Number of enrolments of both sexes in Azerbaijan?
Your answer should be very brief. 4.00e+05. What is the difference between the highest and the lowest Number of enrolments of both sexes in Cyprus?
Your answer should be very brief. 1.71e+04. What is the difference between the highest and the lowest Number of enrolments of both sexes in Oman?
Give a very brief answer. 1.99e+05. What is the difference between the highest and the lowest Number of enrolments of both sexes in Senegal?
Keep it short and to the point. 6.43e+05. 